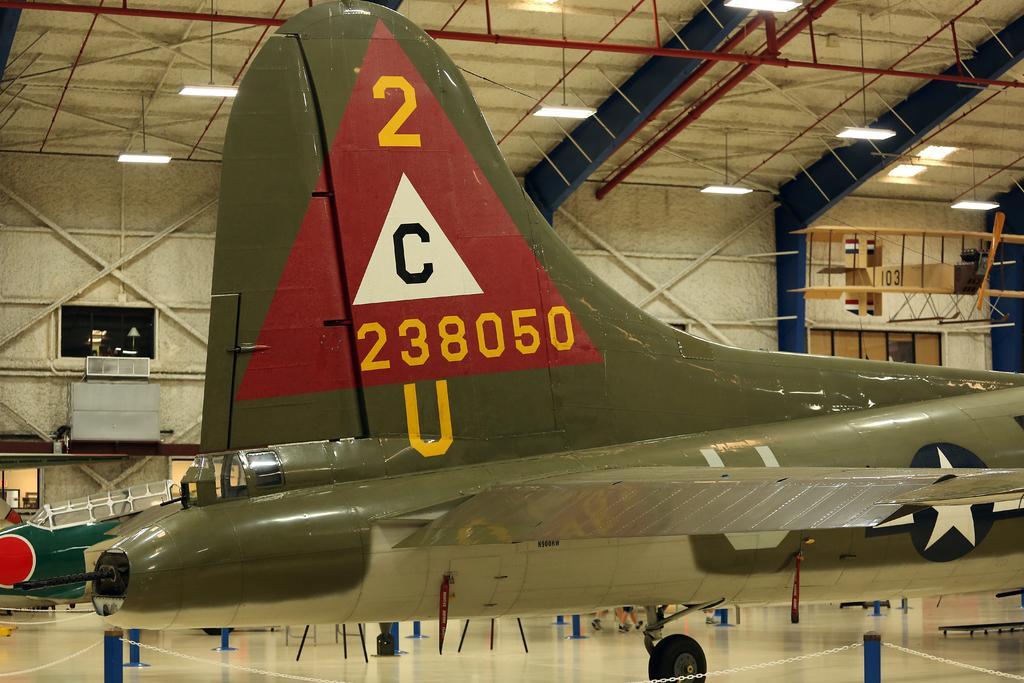<image>
Share a concise interpretation of the image provided. Come see the 2C238050U plane that it on display now. 